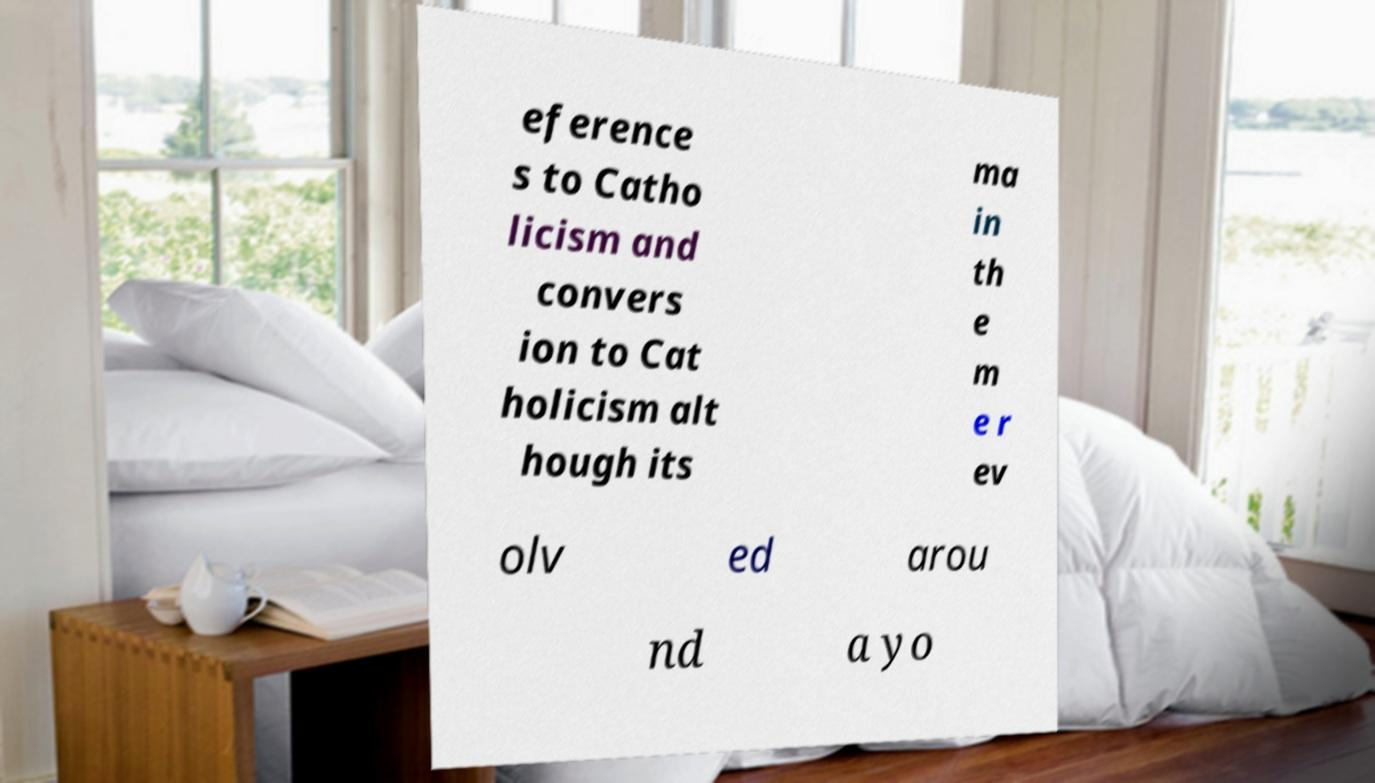Could you assist in decoding the text presented in this image and type it out clearly? eference s to Catho licism and convers ion to Cat holicism alt hough its ma in th e m e r ev olv ed arou nd a yo 